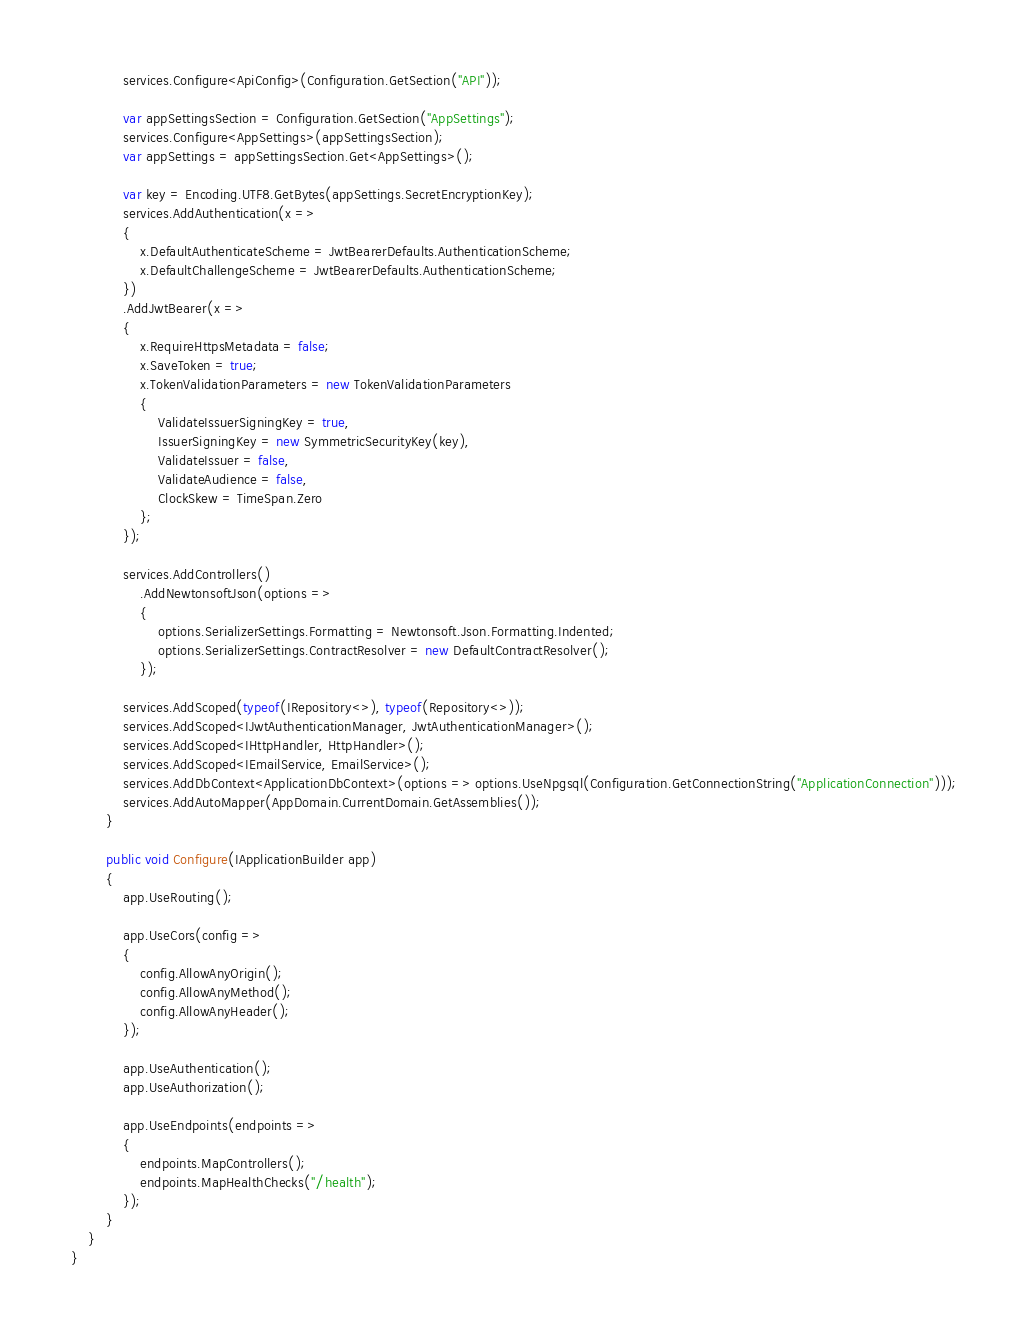Convert code to text. <code><loc_0><loc_0><loc_500><loc_500><_C#_>
            services.Configure<ApiConfig>(Configuration.GetSection("API"));

            var appSettingsSection = Configuration.GetSection("AppSettings");
            services.Configure<AppSettings>(appSettingsSection);
            var appSettings = appSettingsSection.Get<AppSettings>();

            var key = Encoding.UTF8.GetBytes(appSettings.SecretEncryptionKey);
            services.AddAuthentication(x =>
            {
                x.DefaultAuthenticateScheme = JwtBearerDefaults.AuthenticationScheme;
                x.DefaultChallengeScheme = JwtBearerDefaults.AuthenticationScheme;
            })
            .AddJwtBearer(x =>
            {
                x.RequireHttpsMetadata = false;
                x.SaveToken = true;
                x.TokenValidationParameters = new TokenValidationParameters
                {
                    ValidateIssuerSigningKey = true,
                    IssuerSigningKey = new SymmetricSecurityKey(key),
                    ValidateIssuer = false,
                    ValidateAudience = false,
                    ClockSkew = TimeSpan.Zero
                };
            });

            services.AddControllers()
                .AddNewtonsoftJson(options =>
                {
                    options.SerializerSettings.Formatting = Newtonsoft.Json.Formatting.Indented;
                    options.SerializerSettings.ContractResolver = new DefaultContractResolver();
                });

            services.AddScoped(typeof(IRepository<>), typeof(Repository<>));
            services.AddScoped<IJwtAuthenticationManager, JwtAuthenticationManager>();
            services.AddScoped<IHttpHandler, HttpHandler>();
            services.AddScoped<IEmailService, EmailService>();
            services.AddDbContext<ApplicationDbContext>(options => options.UseNpgsql(Configuration.GetConnectionString("ApplicationConnection")));
            services.AddAutoMapper(AppDomain.CurrentDomain.GetAssemblies());
        }

        public void Configure(IApplicationBuilder app)
        {
            app.UseRouting();

            app.UseCors(config =>
            {
                config.AllowAnyOrigin();
                config.AllowAnyMethod();
                config.AllowAnyHeader();
            });

            app.UseAuthentication();
            app.UseAuthorization();

            app.UseEndpoints(endpoints =>
            {
                endpoints.MapControllers();
                endpoints.MapHealthChecks("/health");
            });
        }
    }
}
</code> 